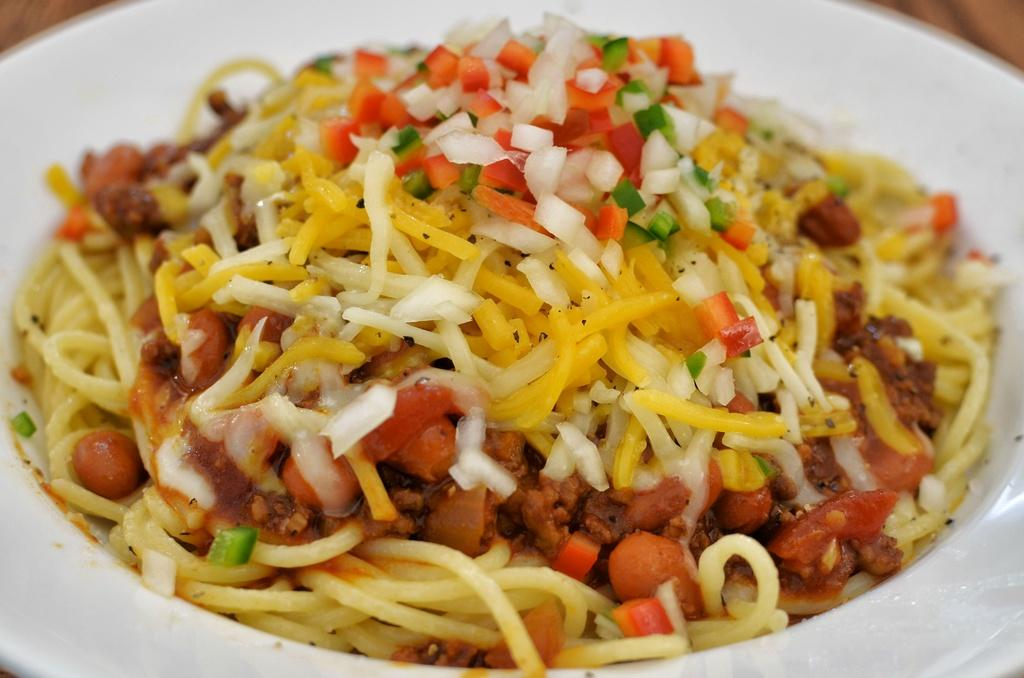What object can be seen in the image that is typically used for serving food? There is a plate in the image that is typically used for serving food. What is on the plate in the image? A food item is present on the plate in the image. What type of mist can be seen surrounding the food item on the plate? There is no mist present in the image; it only shows a plate with a food item on it. 